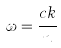Convert formula to latex. <formula><loc_0><loc_0><loc_500><loc_500>\omega = \frac { c k } { n }</formula> 